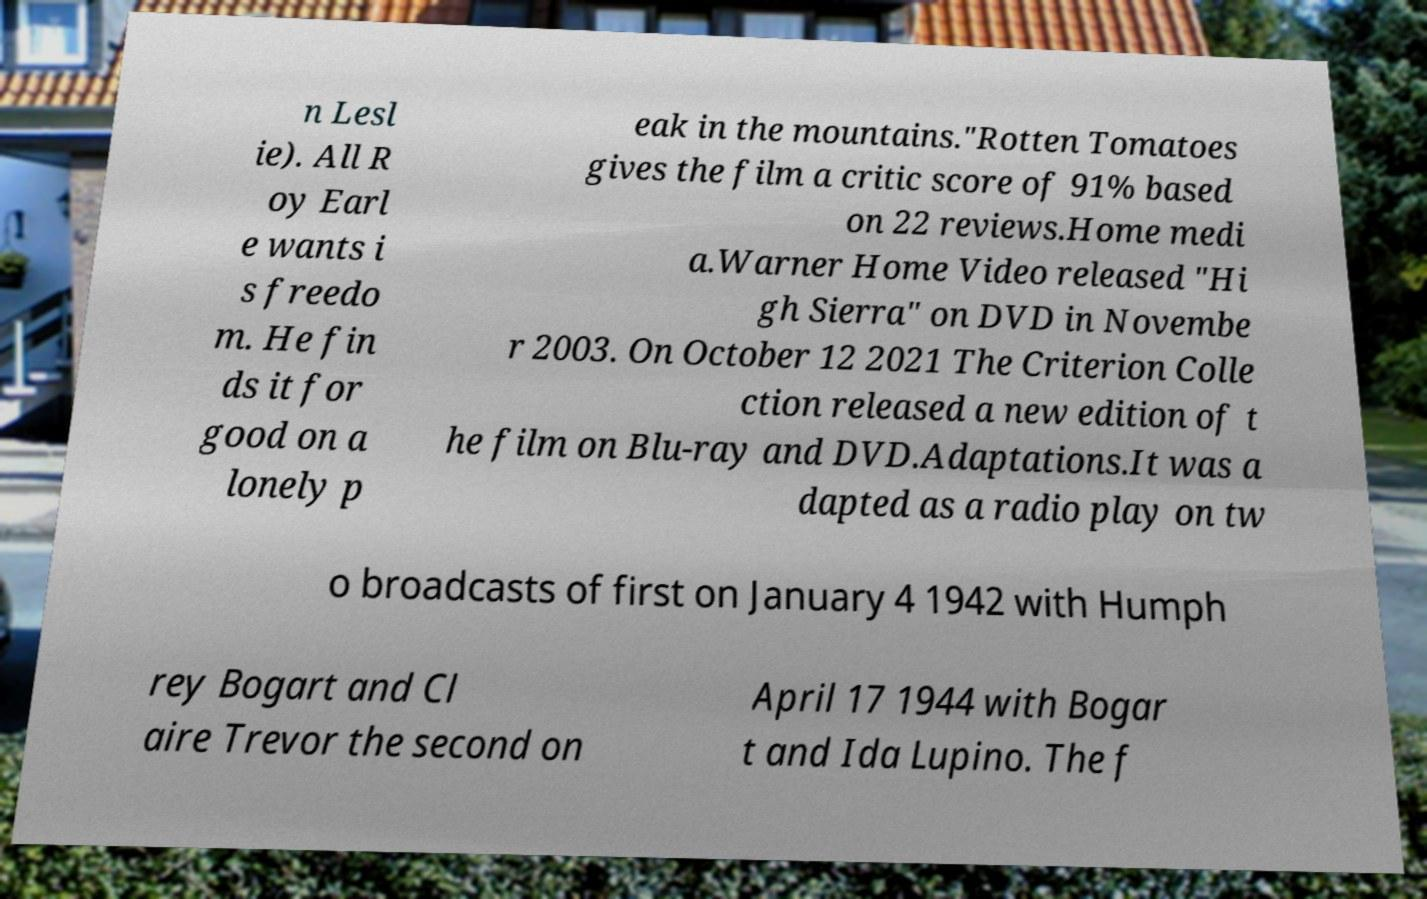There's text embedded in this image that I need extracted. Can you transcribe it verbatim? n Lesl ie). All R oy Earl e wants i s freedo m. He fin ds it for good on a lonely p eak in the mountains."Rotten Tomatoes gives the film a critic score of 91% based on 22 reviews.Home medi a.Warner Home Video released "Hi gh Sierra" on DVD in Novembe r 2003. On October 12 2021 The Criterion Colle ction released a new edition of t he film on Blu-ray and DVD.Adaptations.It was a dapted as a radio play on tw o broadcasts of first on January 4 1942 with Humph rey Bogart and Cl aire Trevor the second on April 17 1944 with Bogar t and Ida Lupino. The f 